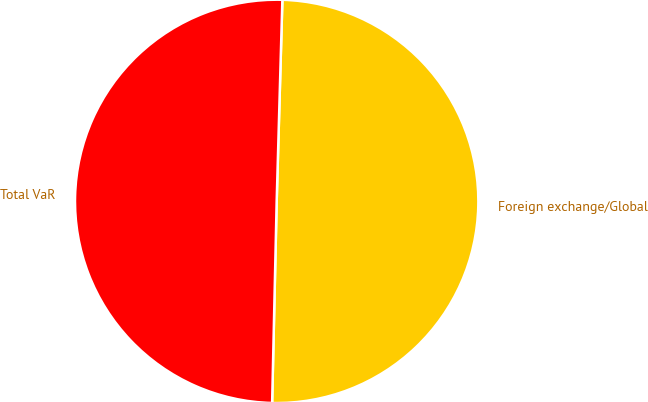Convert chart to OTSL. <chart><loc_0><loc_0><loc_500><loc_500><pie_chart><fcel>Foreign exchange/Global<fcel>Total VaR<nl><fcel>49.91%<fcel>50.09%<nl></chart> 